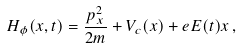<formula> <loc_0><loc_0><loc_500><loc_500>H _ { \phi } ( x , t ) = \frac { p _ { x } ^ { 2 } } { 2 m } + V _ { c } ( x ) + e E ( t ) x \, ,</formula> 